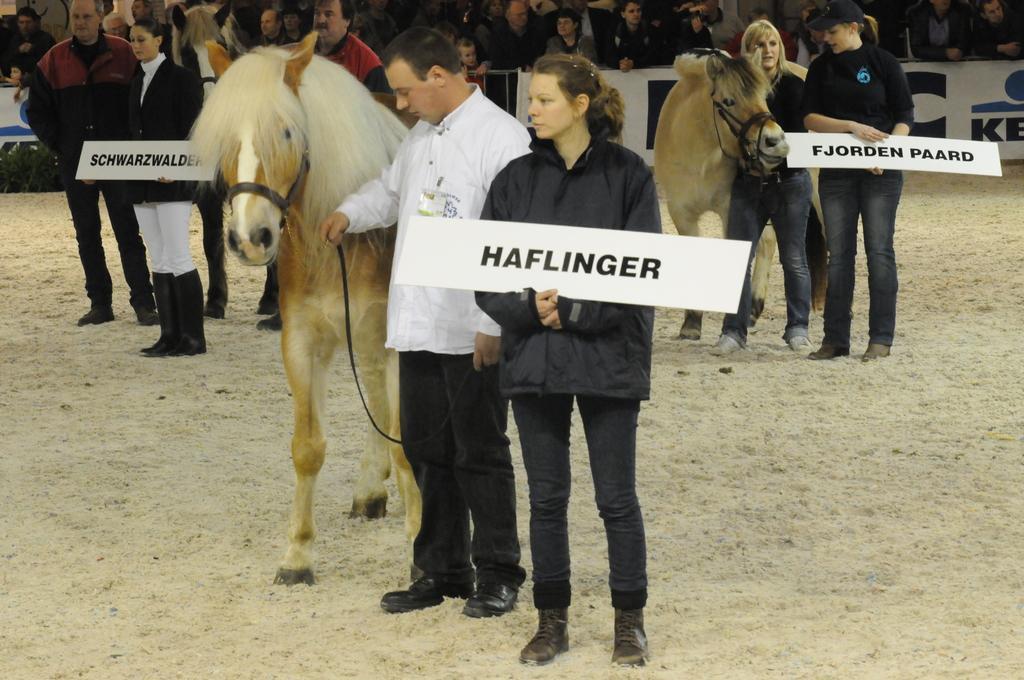Could you give a brief overview of what you see in this image? In the picture we can see a many people standing and two people are standing near the horse which is white in color and man is wearing a white shirt with black pant and shoe, and the woman is wearing a black dress, just behind him there are an other two people standing near the horse and wearing the black dress. 